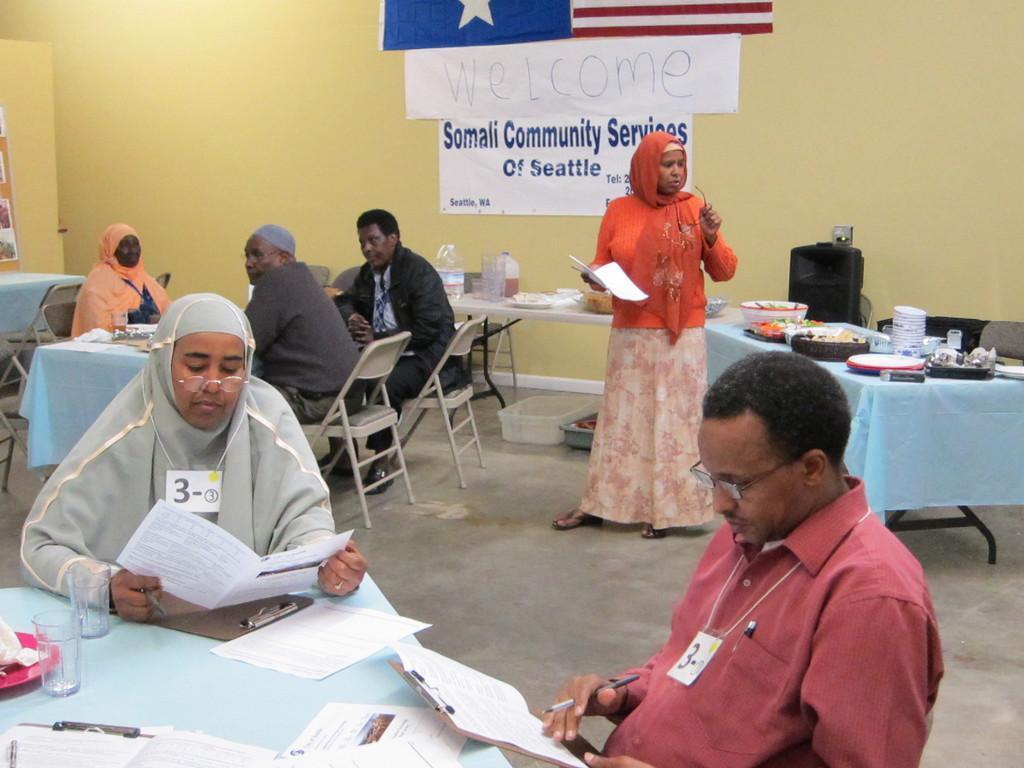How would you summarize this image in a sentence or two? In the image in the center we can one woman standing and holding papers. And we can see few people were sitting on the chair around the table and few people were holding some objects. On the tables,we can see cloth,papers,glasses,plates,plank,pen,tissue paper and few other objects. In the background there is a wall,flag,speaker,board,banners,tables and chairs. On the table,we can see clothes,bowls,plates,baskets,cans,containers and few other objects. 